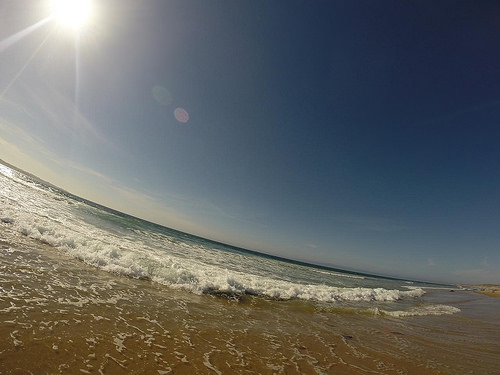<image>
Is the sea above the beach? No. The sea is not positioned above the beach. The vertical arrangement shows a different relationship. 